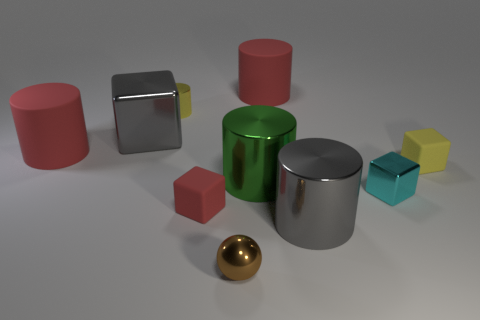Do the tiny shiny cylinder and the small block that is behind the green object have the same color?
Your response must be concise. Yes. What material is the tiny brown ball in front of the gray thing that is behind the matte cylinder on the left side of the green metal cylinder?
Your answer should be compact. Metal. What shape is the tiny metallic object that is in front of the tiny cyan shiny cube?
Offer a terse response. Sphere. What size is the gray block that is the same material as the green cylinder?
Make the answer very short. Large. How many brown shiny things are the same shape as the large green thing?
Your answer should be very brief. 0. Do the tiny matte cube on the right side of the gray cylinder and the small cylinder have the same color?
Your answer should be very brief. Yes. There is a large matte thing to the right of the big rubber thing that is in front of the small shiny cylinder; what number of big gray shiny objects are to the left of it?
Your response must be concise. 1. What number of matte objects are to the right of the big green thing and left of the large gray metallic cube?
Provide a succinct answer. 0. What is the shape of the metallic thing that is the same color as the big cube?
Your answer should be very brief. Cylinder. Are the brown ball and the tiny cyan thing made of the same material?
Your answer should be compact. Yes. 